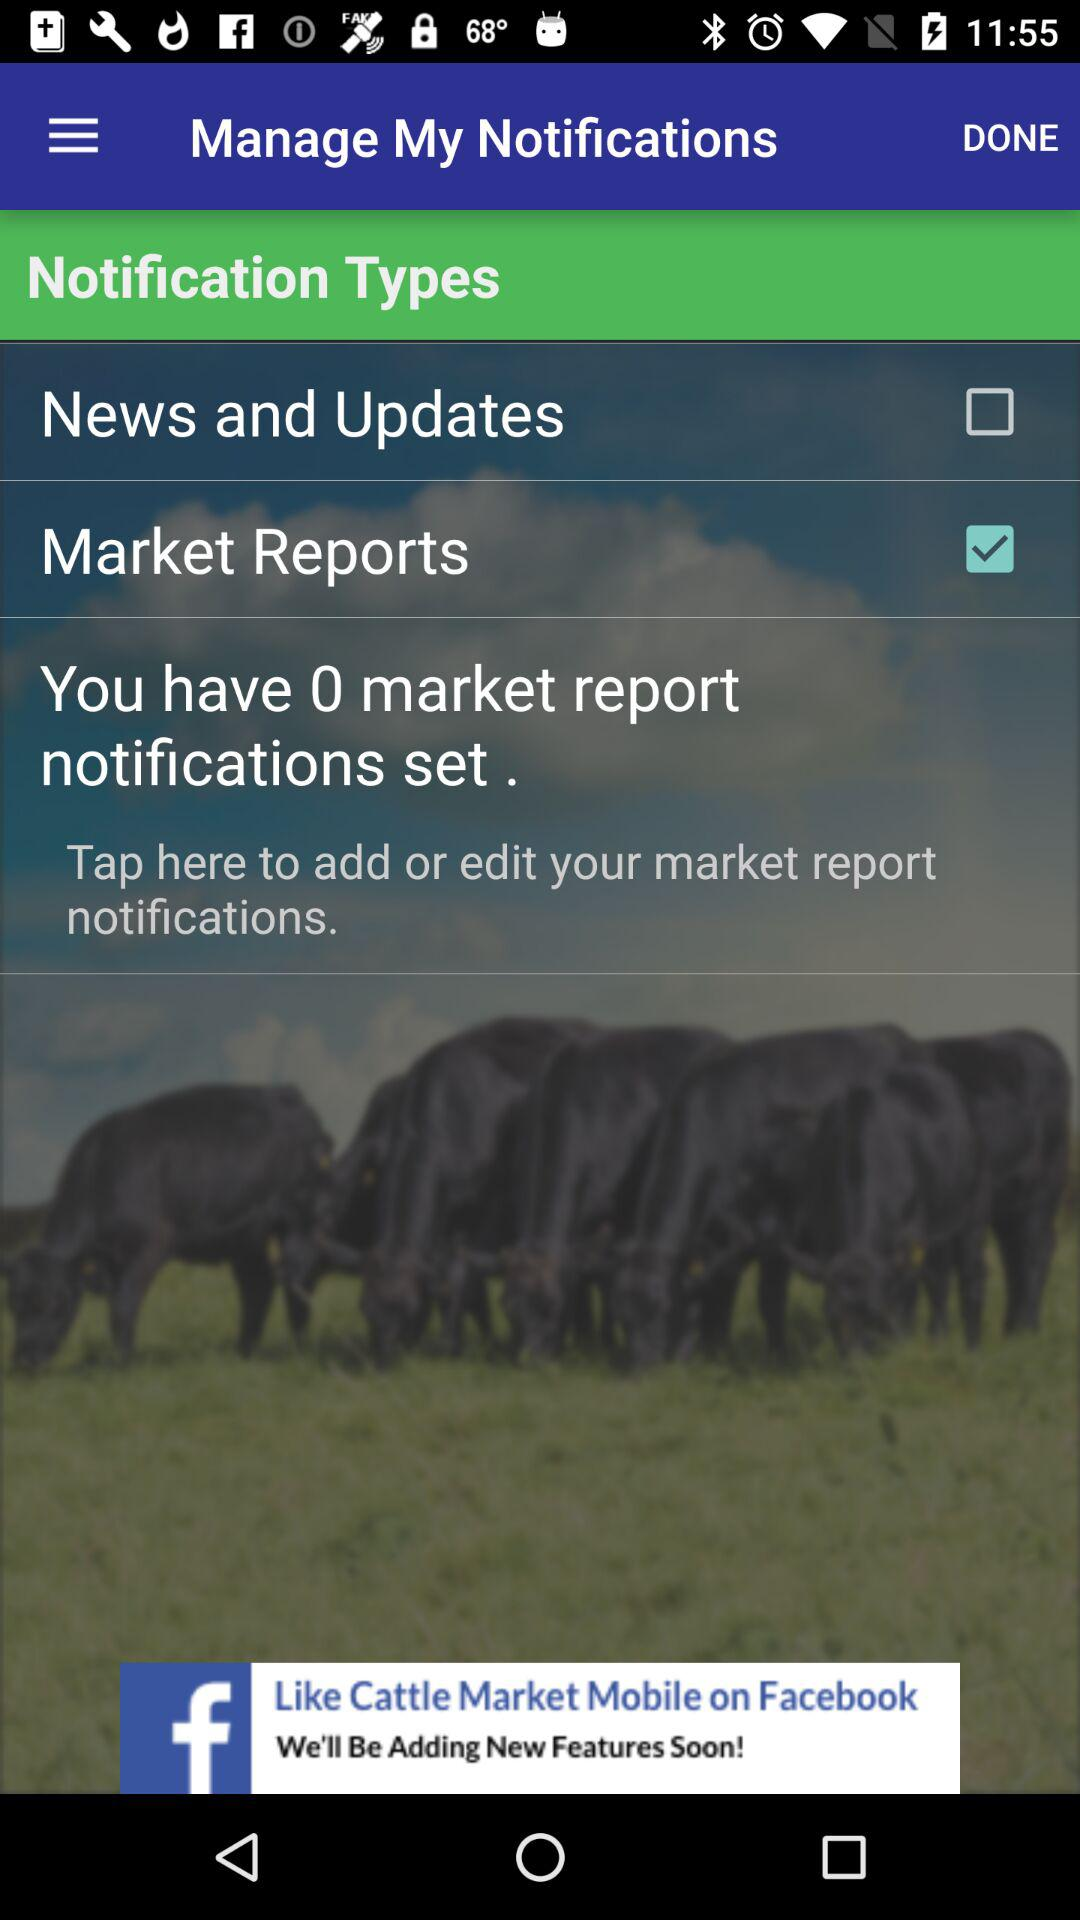Which notification type is selected? The selected notification type is "Market Reports". 